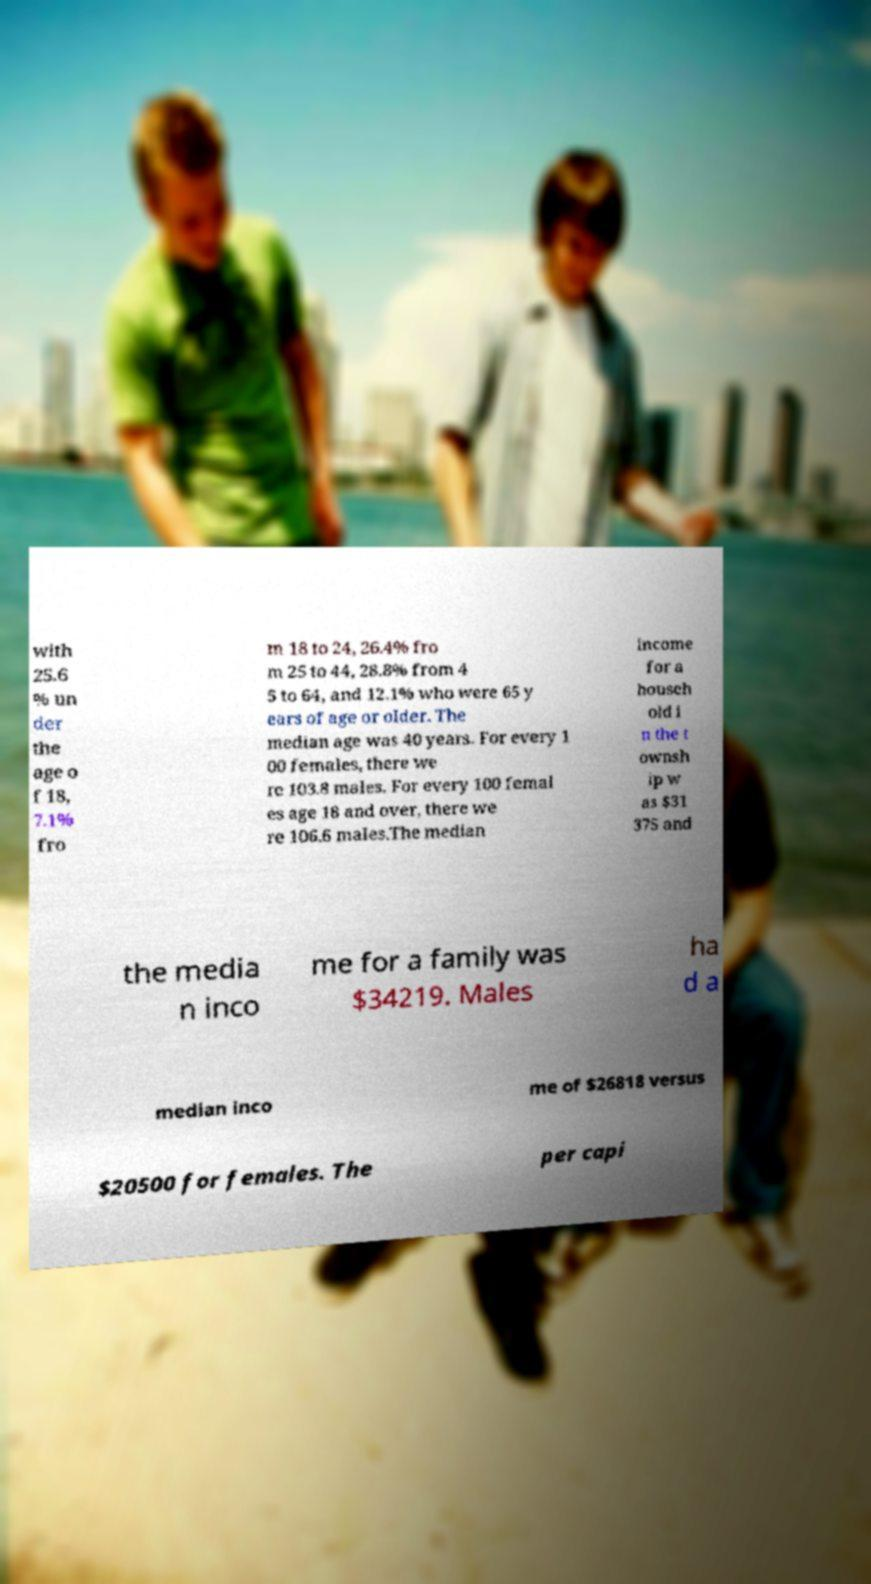I need the written content from this picture converted into text. Can you do that? with 25.6 % un der the age o f 18, 7.1% fro m 18 to 24, 26.4% fro m 25 to 44, 28.8% from 4 5 to 64, and 12.1% who were 65 y ears of age or older. The median age was 40 years. For every 1 00 females, there we re 103.8 males. For every 100 femal es age 18 and over, there we re 106.6 males.The median income for a househ old i n the t ownsh ip w as $31 375 and the media n inco me for a family was $34219. Males ha d a median inco me of $26818 versus $20500 for females. The per capi 